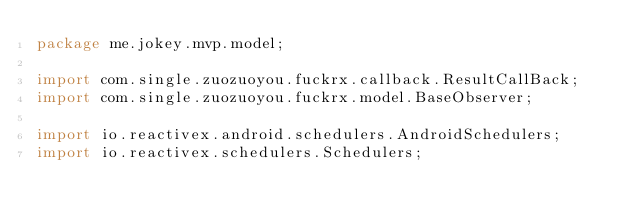Convert code to text. <code><loc_0><loc_0><loc_500><loc_500><_Java_>package me.jokey.mvp.model;

import com.single.zuozuoyou.fuckrx.callback.ResultCallBack;
import com.single.zuozuoyou.fuckrx.model.BaseObserver;

import io.reactivex.android.schedulers.AndroidSchedulers;
import io.reactivex.schedulers.Schedulers;</code> 